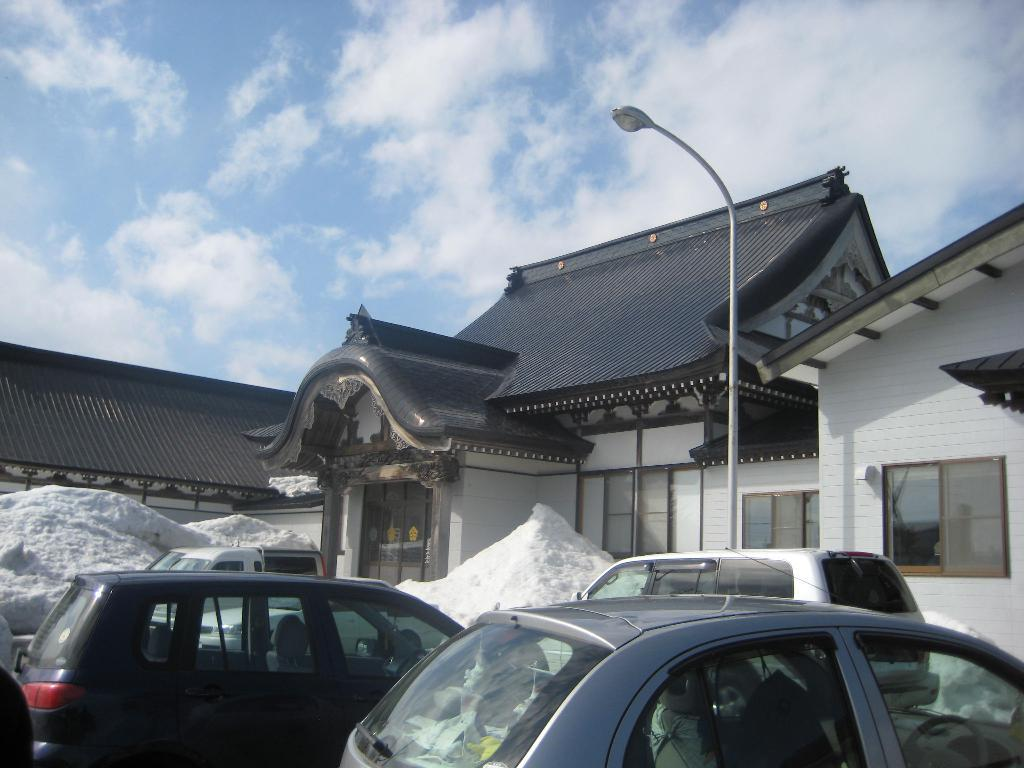What can be seen in the image besides the house in the background? There are vehicles in the image. What is the condition of the ground in the image? Snow is visible on the ground. What type of lighting is present in the image? There is a street light in the image. What is visible at the top of the image? The sky is visible at the top of the image. How many chickens can be seen walking on the street light in the image? There are no chickens present in the image, and the street light is not a place for walking. What type of society is depicted in the image? The image does not depict a society; it shows vehicles, a house, snow, a street light, and the sky. 